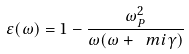Convert formula to latex. <formula><loc_0><loc_0><loc_500><loc_500>\varepsilon ( \omega ) = 1 - \frac { \omega _ { P } ^ { 2 } } { \omega ( \omega + \ m i \gamma ) }</formula> 